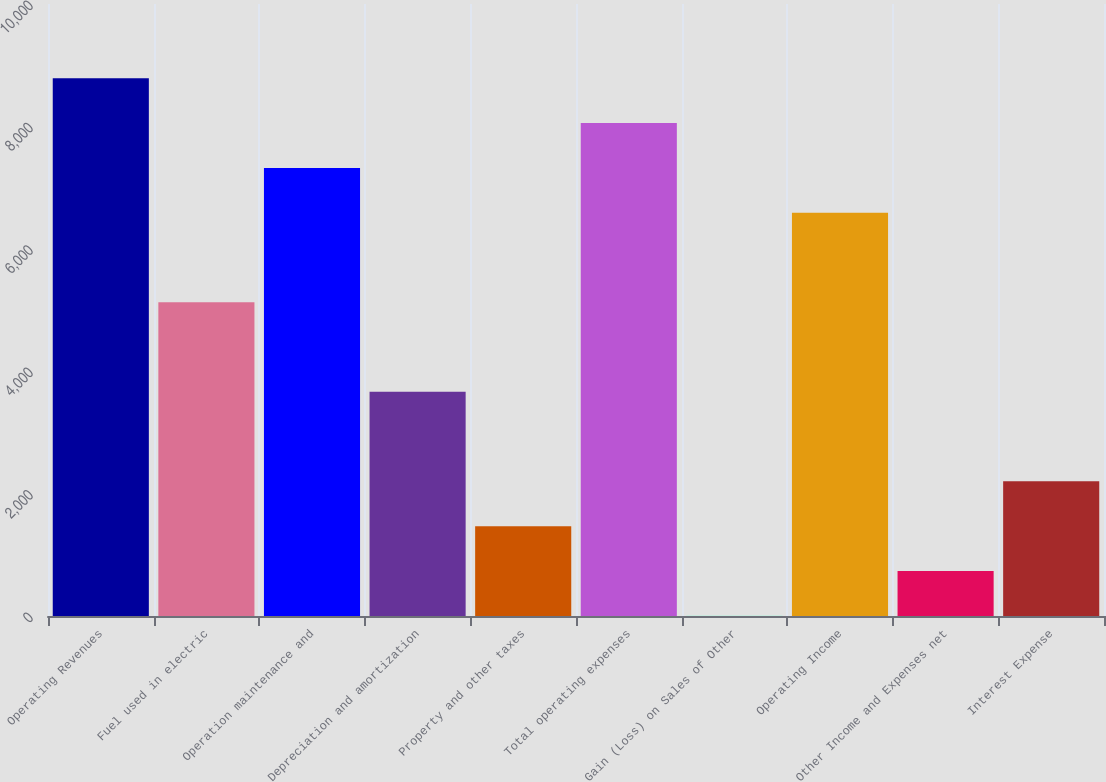Convert chart. <chart><loc_0><loc_0><loc_500><loc_500><bar_chart><fcel>Operating Revenues<fcel>Fuel used in electric<fcel>Operation maintenance and<fcel>Depreciation and amortization<fcel>Property and other taxes<fcel>Total operating expenses<fcel>Gain (Loss) on Sales of Other<fcel>Operating Income<fcel>Other Income and Expenses net<fcel>Interest Expense<nl><fcel>8785.4<fcel>5126.9<fcel>7322<fcel>3663.5<fcel>1468.4<fcel>8053.7<fcel>5<fcel>6590.3<fcel>736.7<fcel>2200.1<nl></chart> 